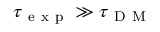<formula> <loc_0><loc_0><loc_500><loc_500>\tau _ { e x p } \gg \tau _ { D M }</formula> 